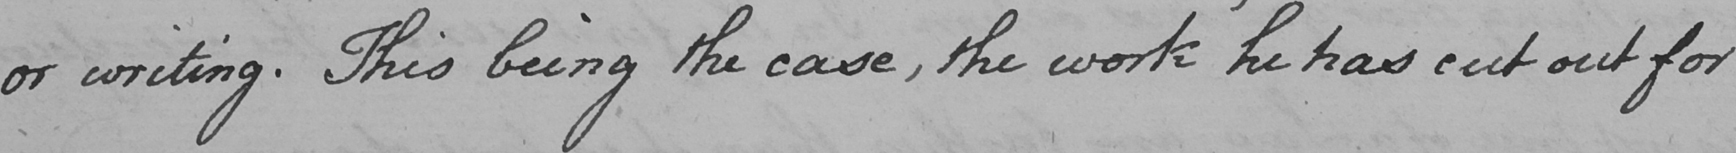Please provide the text content of this handwritten line. or writing . This being the case , the work he has cut out for 